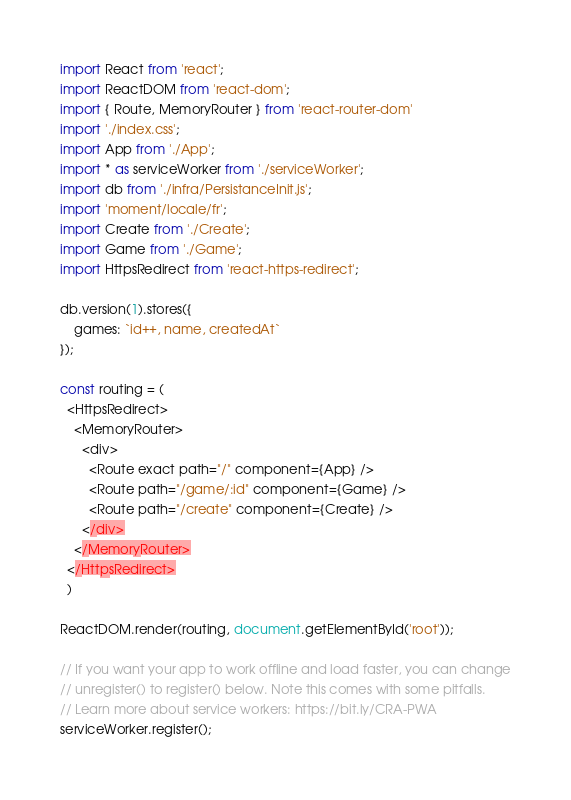<code> <loc_0><loc_0><loc_500><loc_500><_JavaScript_>import React from 'react';
import ReactDOM from 'react-dom';
import { Route, MemoryRouter } from 'react-router-dom'
import './index.css';
import App from './App';
import * as serviceWorker from './serviceWorker';
import db from './infra/PersistanceInit.js';
import 'moment/locale/fr';
import Create from './Create';
import Game from './Game';
import HttpsRedirect from 'react-https-redirect';

db.version(1).stores({
    games: `id++, name, createdAt`
});

const routing = (
  <HttpsRedirect>
    <MemoryRouter>
      <div>
        <Route exact path="/" component={App} />
        <Route path="/game/:id" component={Game} />
        <Route path="/create" component={Create} />
      </div>
    </MemoryRouter>
  </HttpsRedirect>
  )

ReactDOM.render(routing, document.getElementById('root'));

// If you want your app to work offline and load faster, you can change
// unregister() to register() below. Note this comes with some pitfalls.
// Learn more about service workers: https://bit.ly/CRA-PWA
serviceWorker.register();
</code> 